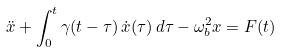Convert formula to latex. <formula><loc_0><loc_0><loc_500><loc_500>\ddot { x } + \int _ { 0 } ^ { t } \gamma ( t - \tau ) \, \dot { x } ( \tau ) \, d \tau - \omega _ { b } ^ { 2 } x = F ( t )</formula> 